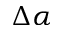<formula> <loc_0><loc_0><loc_500><loc_500>\Delta \alpha</formula> 